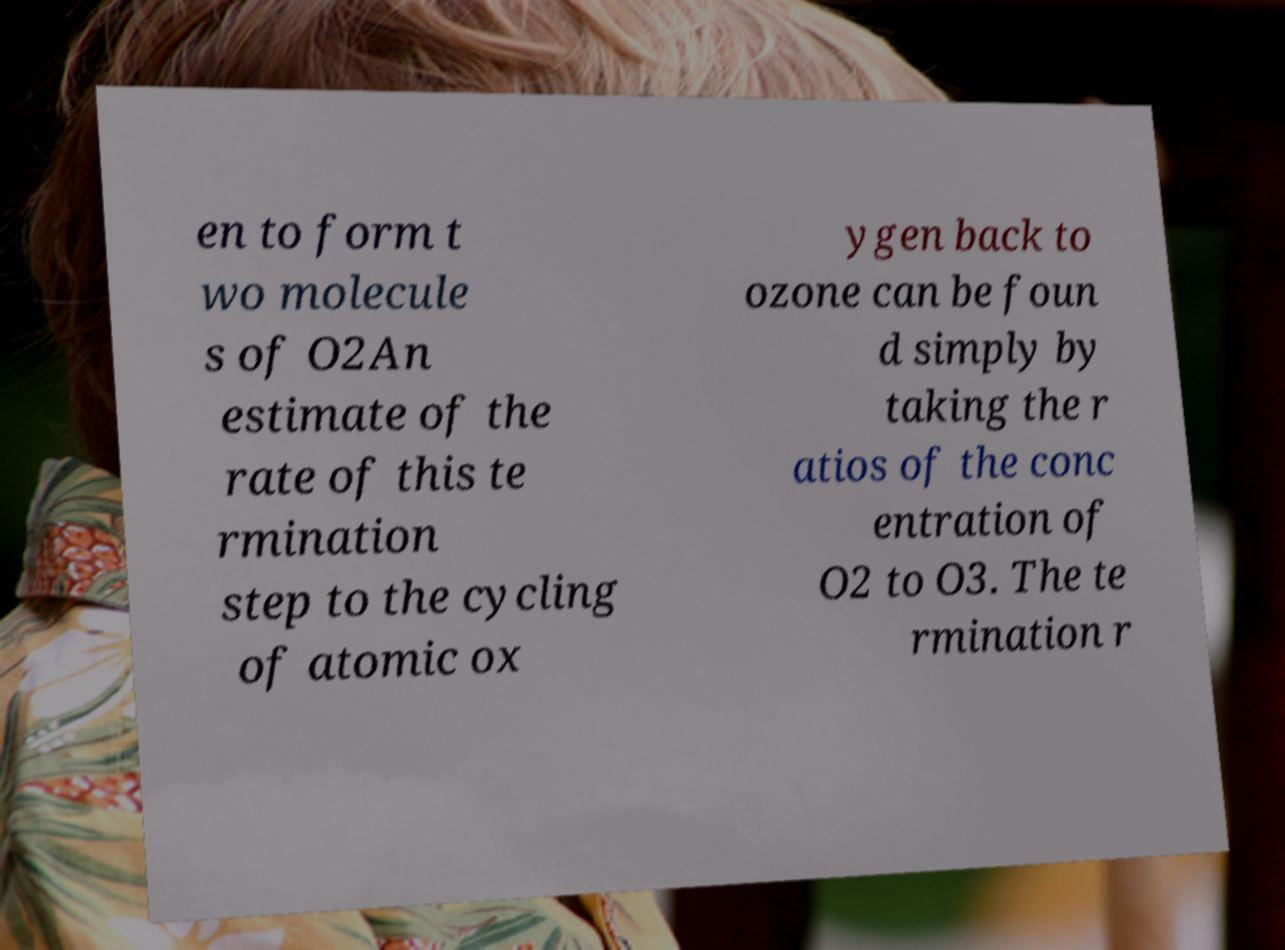Could you assist in decoding the text presented in this image and type it out clearly? en to form t wo molecule s of O2An estimate of the rate of this te rmination step to the cycling of atomic ox ygen back to ozone can be foun d simply by taking the r atios of the conc entration of O2 to O3. The te rmination r 